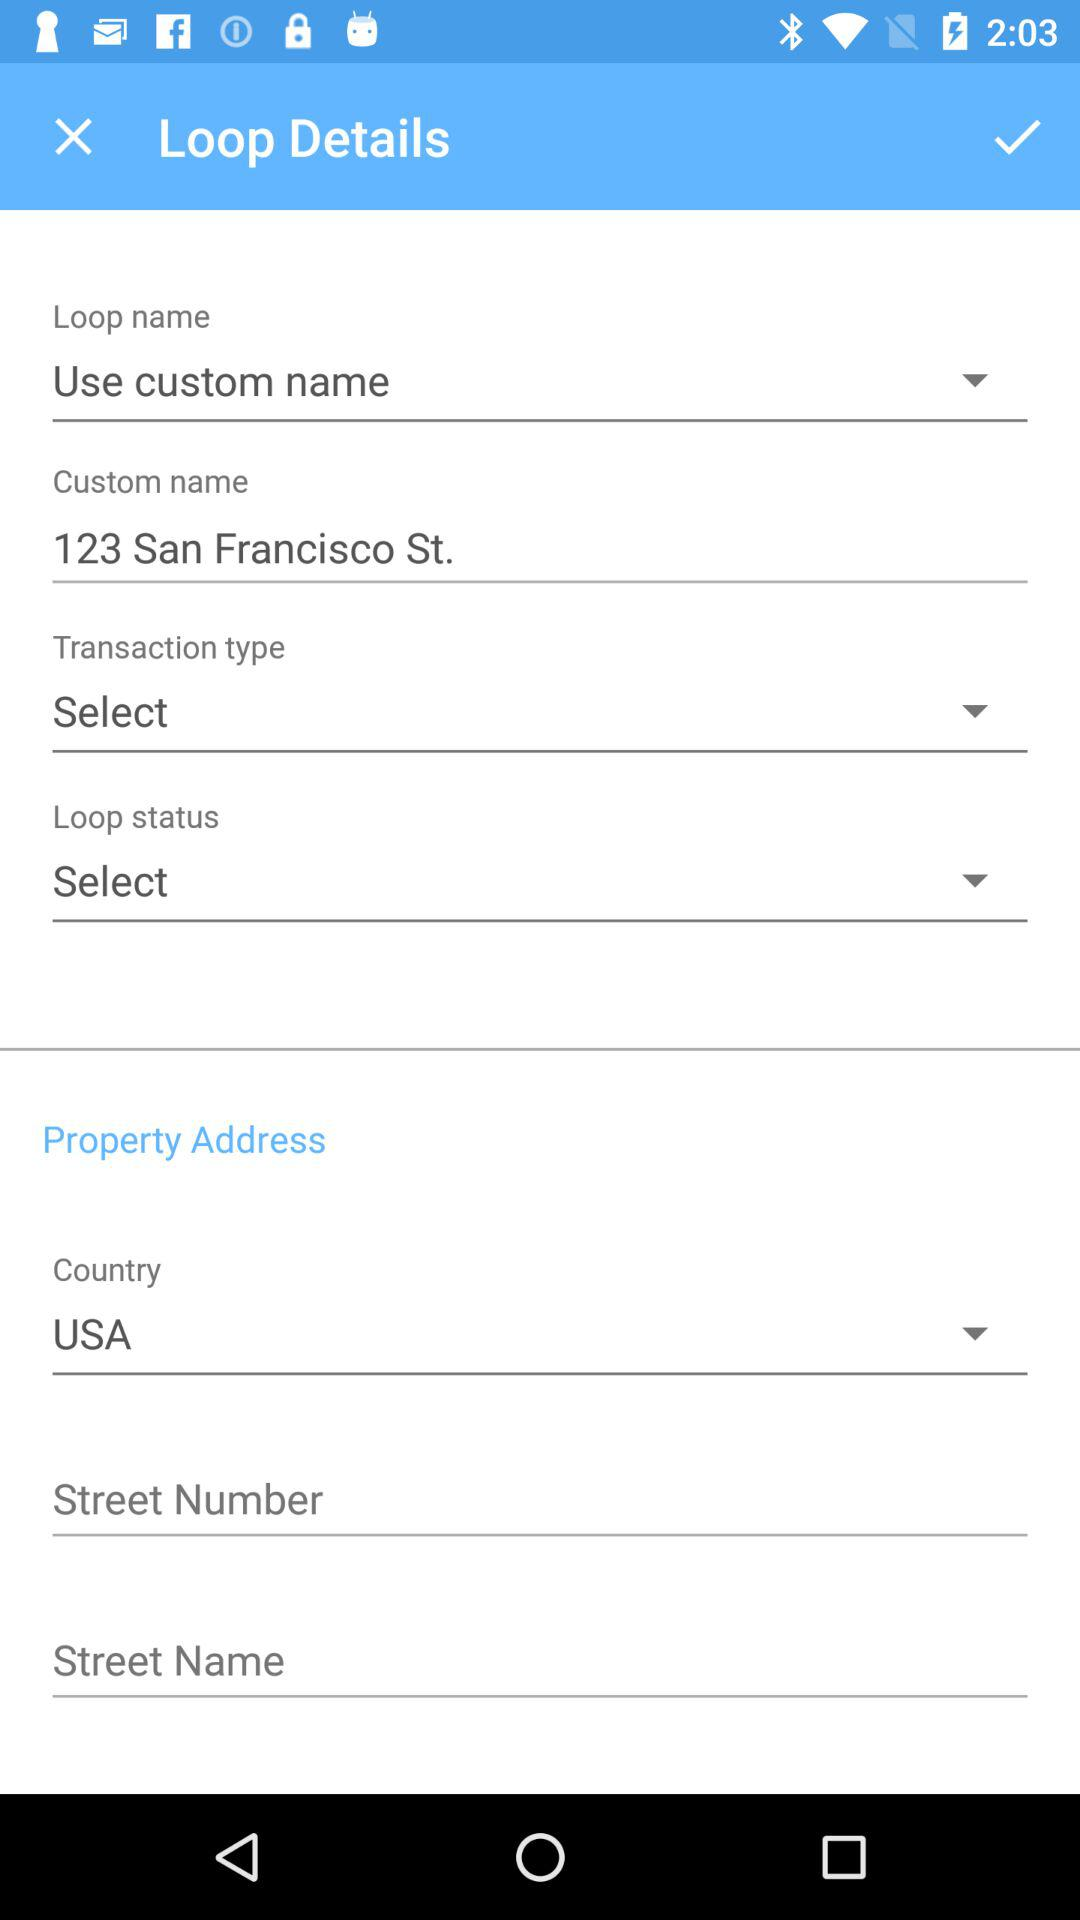What is the custom name? The custom name is 123 San Francisco St. 